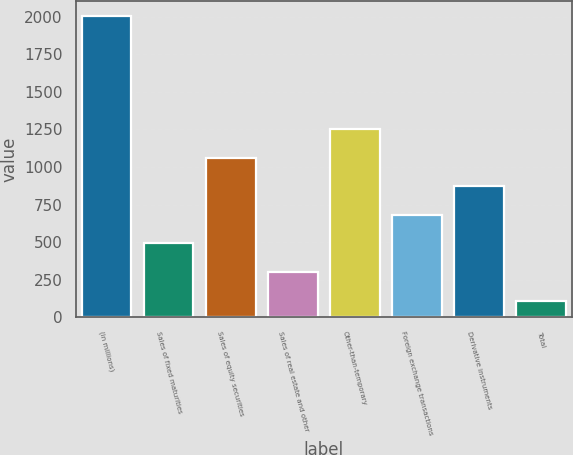Convert chart. <chart><loc_0><loc_0><loc_500><loc_500><bar_chart><fcel>(in millions)<fcel>Sales of fixed maturities<fcel>Sales of equity securities<fcel>Sales of real estate and other<fcel>Other-than-temporary<fcel>Foreign exchange transactions<fcel>Derivative instruments<fcel>Total<nl><fcel>2006<fcel>493<fcel>1063<fcel>303<fcel>1253<fcel>683<fcel>873<fcel>106<nl></chart> 